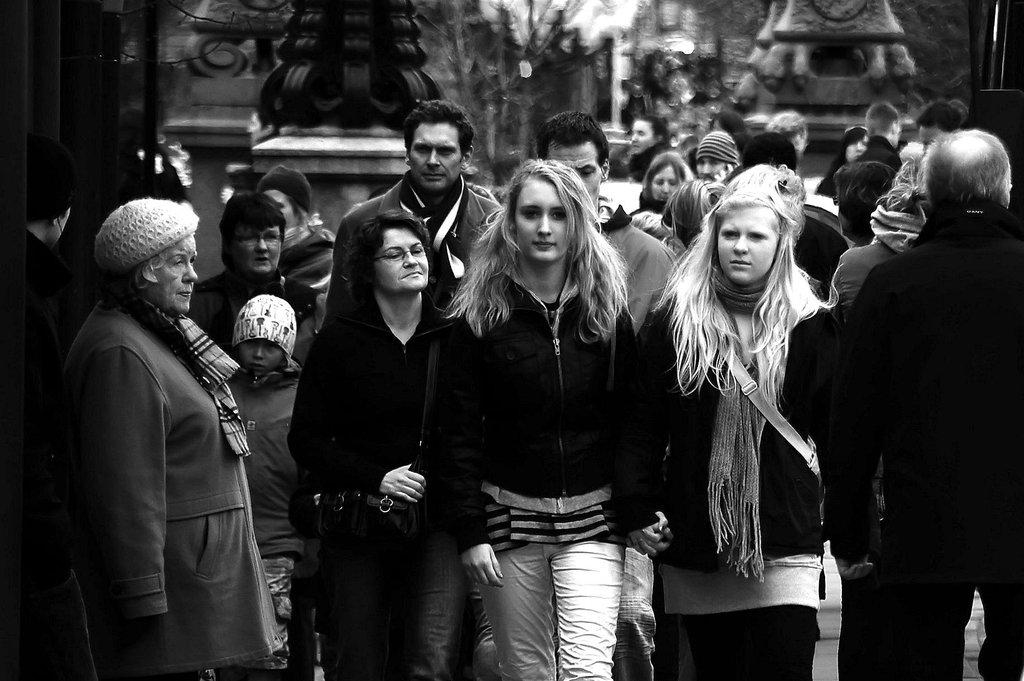What are the people in the image doing? There is a group of persons standing and walking in the center of the image. What can be seen in the background of the image? There are pillars and a wall in the background of the image. How many beds are visible in the image? There are no beds present in the image. What type of memory is being stored in the image? The image does not depict any memory being stored or recalled. 